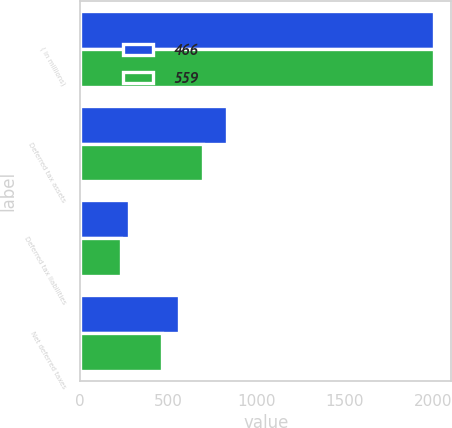<chart> <loc_0><loc_0><loc_500><loc_500><stacked_bar_chart><ecel><fcel>( in millions)<fcel>Deferred tax assets<fcel>Deferred tax liabilities<fcel>Net deferred taxes<nl><fcel>466<fcel>2004<fcel>834<fcel>275<fcel>559<nl><fcel>559<fcel>2003<fcel>698<fcel>232<fcel>466<nl></chart> 